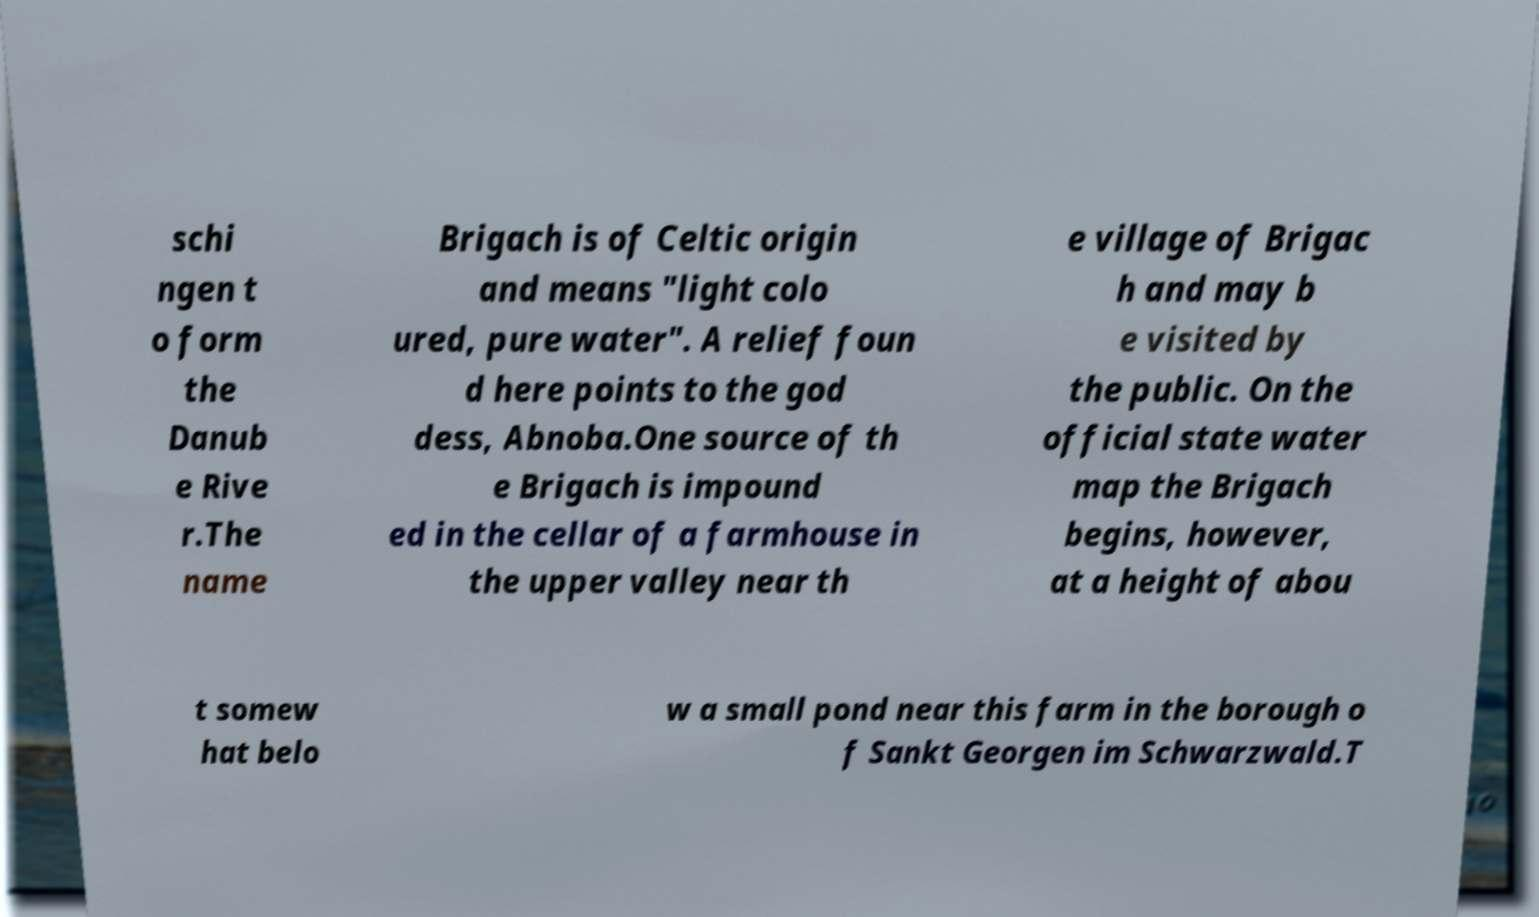Could you extract and type out the text from this image? schi ngen t o form the Danub e Rive r.The name Brigach is of Celtic origin and means "light colo ured, pure water". A relief foun d here points to the god dess, Abnoba.One source of th e Brigach is impound ed in the cellar of a farmhouse in the upper valley near th e village of Brigac h and may b e visited by the public. On the official state water map the Brigach begins, however, at a height of abou t somew hat belo w a small pond near this farm in the borough o f Sankt Georgen im Schwarzwald.T 